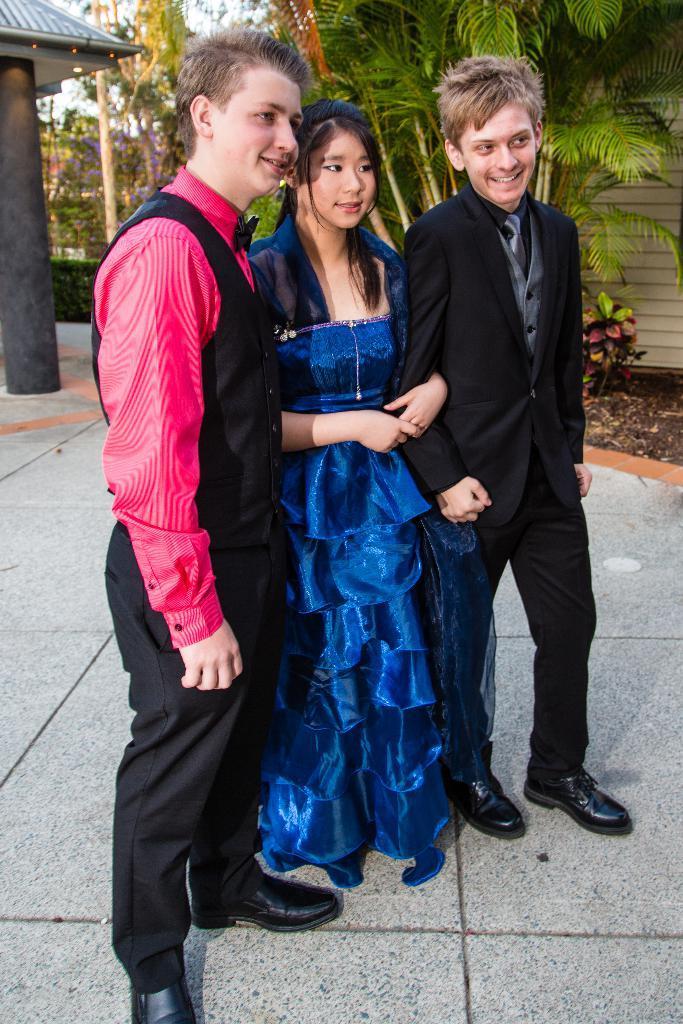Could you give a brief overview of what you see in this image? Here I can see two boys and a girl are standing and smiling by looking at the right side. In the background there are many plants and trees. on the left side there is a pillar. 